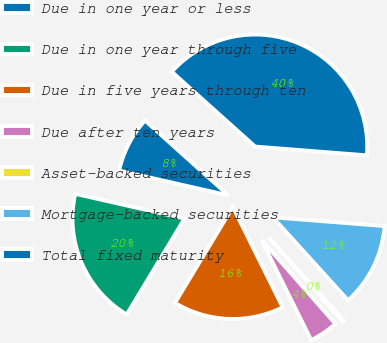<chart> <loc_0><loc_0><loc_500><loc_500><pie_chart><fcel>Due in one year or less<fcel>Due in one year through five<fcel>Due in five years through ten<fcel>Due after ten years<fcel>Asset-backed securities<fcel>Mortgage-backed securities<fcel>Total fixed maturity<nl><fcel>8.1%<fcel>19.91%<fcel>15.97%<fcel>4.16%<fcel>0.22%<fcel>12.04%<fcel>39.61%<nl></chart> 